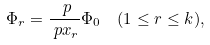<formula> <loc_0><loc_0><loc_500><loc_500>& \Phi _ { r } = \frac { \ p } { \ p x _ { r } } \Phi _ { 0 } \quad ( 1 \leq r \leq k ) ,</formula> 